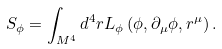Convert formula to latex. <formula><loc_0><loc_0><loc_500><loc_500>S _ { \phi } = \int _ { M ^ { 4 } } d ^ { 4 } r L _ { \phi } \left ( \phi , \partial _ { \mu } \phi , r ^ { \mu } \right ) .</formula> 